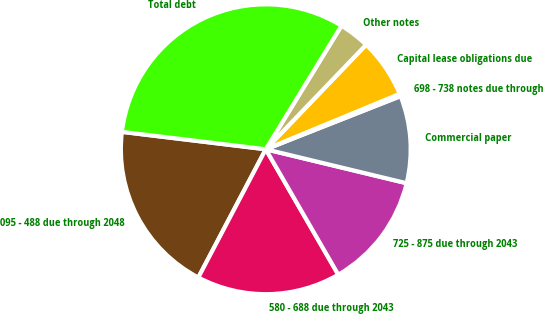Convert chart to OTSL. <chart><loc_0><loc_0><loc_500><loc_500><pie_chart><fcel>095 - 488 due through 2048<fcel>580 - 688 due through 2043<fcel>725 - 875 due through 2043<fcel>Commercial paper<fcel>698 - 738 notes due through<fcel>Capital lease obligations due<fcel>Other notes<fcel>Total debt<nl><fcel>19.21%<fcel>16.05%<fcel>12.89%<fcel>9.74%<fcel>0.27%<fcel>6.58%<fcel>3.43%<fcel>31.83%<nl></chart> 